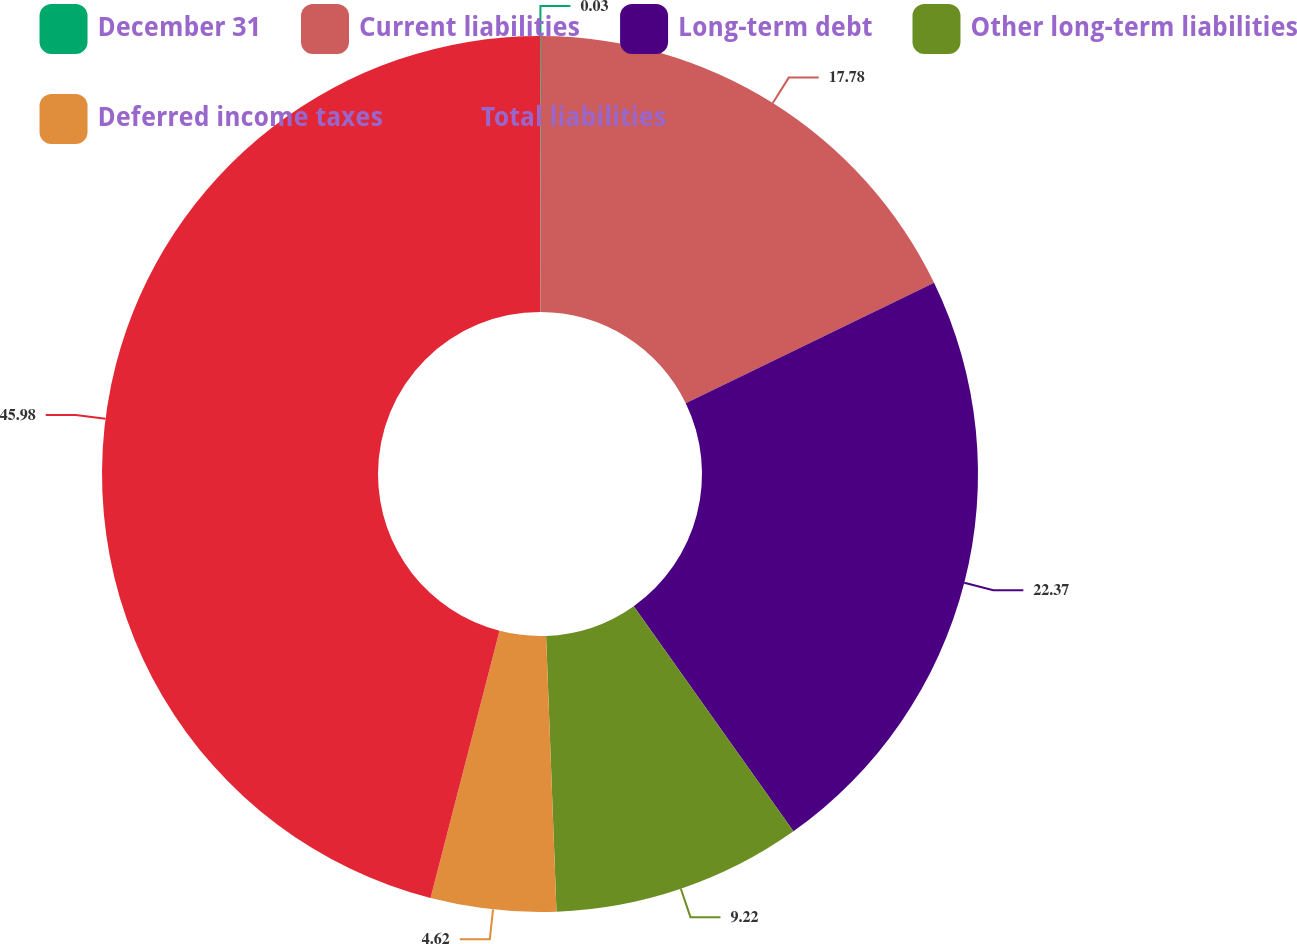Convert chart to OTSL. <chart><loc_0><loc_0><loc_500><loc_500><pie_chart><fcel>December 31<fcel>Current liabilities<fcel>Long-term debt<fcel>Other long-term liabilities<fcel>Deferred income taxes<fcel>Total liabilities<nl><fcel>0.03%<fcel>17.78%<fcel>22.37%<fcel>9.22%<fcel>4.62%<fcel>45.98%<nl></chart> 